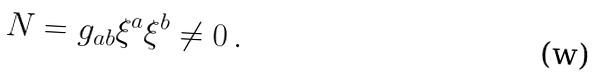<formula> <loc_0><loc_0><loc_500><loc_500>N = g _ { a b } \xi ^ { a } \xi ^ { b } \neq 0 \, .</formula> 